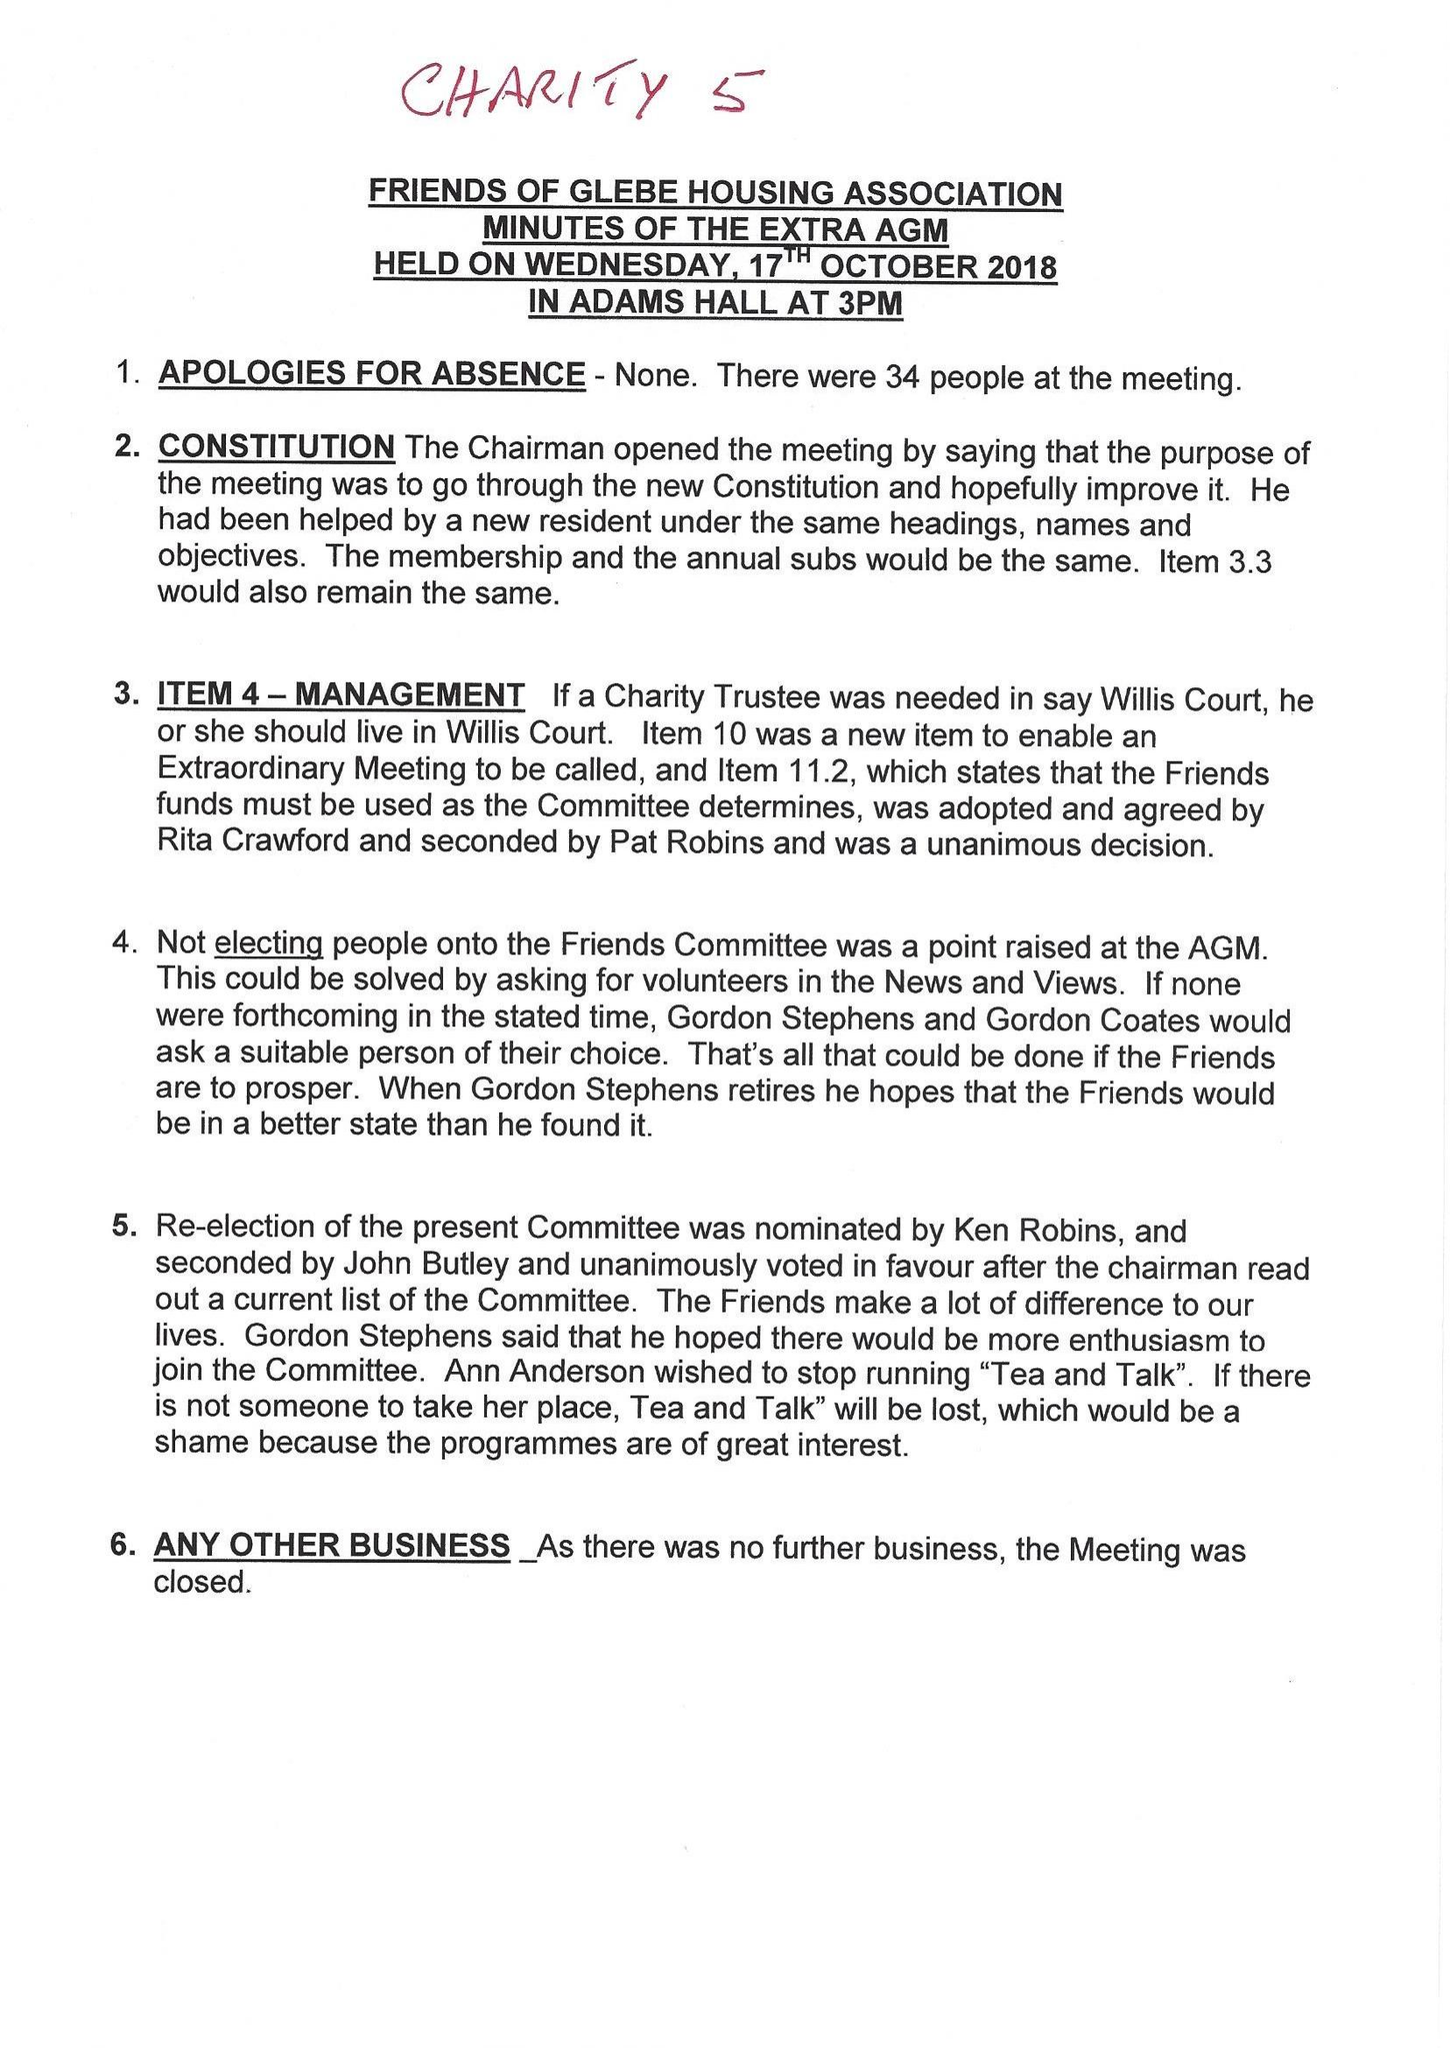What is the value for the address__street_line?
Answer the question using a single word or phrase. BENCURTIS PARK 